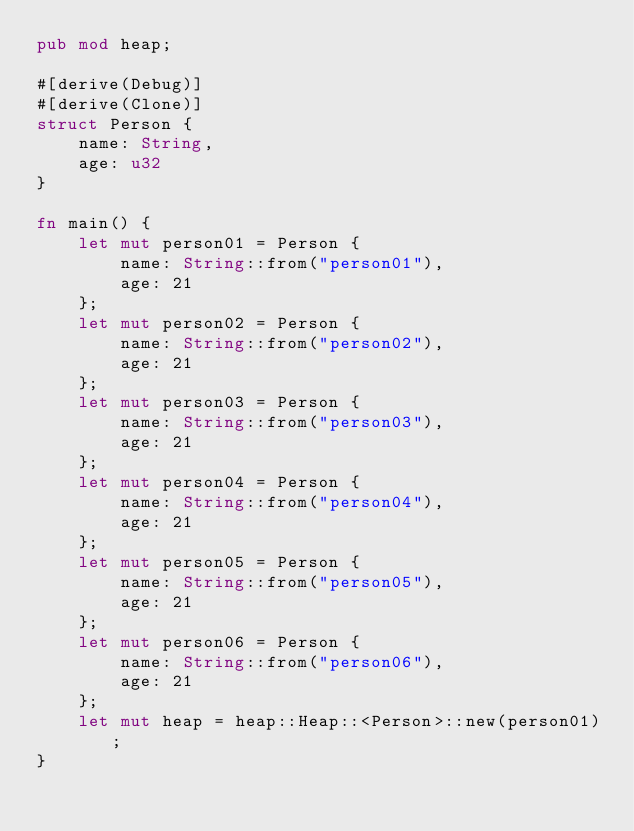Convert code to text. <code><loc_0><loc_0><loc_500><loc_500><_Rust_>pub mod heap;

#[derive(Debug)]
#[derive(Clone)]
struct Person {
    name: String,
    age: u32
}

fn main() {
    let mut person01 = Person {
        name: String::from("person01"),
        age: 21
    };
    let mut person02 = Person {
        name: String::from("person02"),
        age: 21
    };
    let mut person03 = Person {
        name: String::from("person03"),
        age: 21
    };
    let mut person04 = Person {
        name: String::from("person04"),
        age: 21
    };
    let mut person05 = Person {
        name: String::from("person05"),
        age: 21
    };
    let mut person06 = Person {
        name: String::from("person06"),
        age: 21
    };
    let mut heap = heap::Heap::<Person>::new(person01);
}</code> 